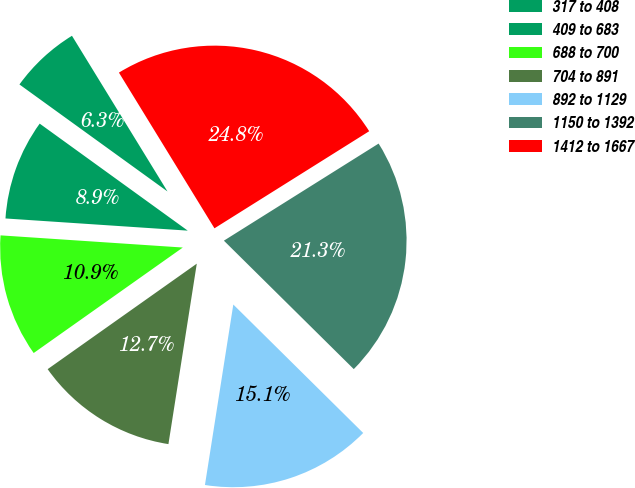Convert chart. <chart><loc_0><loc_0><loc_500><loc_500><pie_chart><fcel>317 to 408<fcel>409 to 683<fcel>688 to 700<fcel>704 to 891<fcel>892 to 1129<fcel>1150 to 1392<fcel>1412 to 1667<nl><fcel>6.28%<fcel>8.9%<fcel>10.86%<fcel>12.72%<fcel>15.07%<fcel>21.33%<fcel>24.84%<nl></chart> 